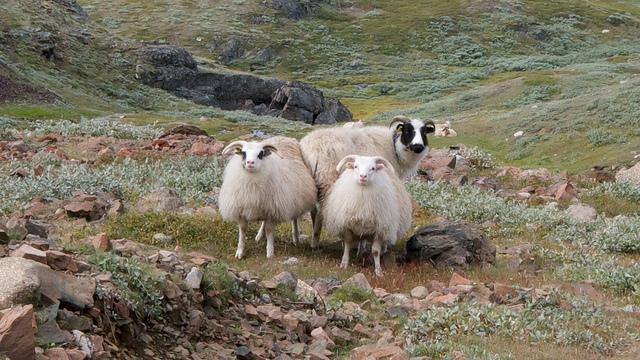Are there rocks in the picture?
Short answer required. Yes. Has the sheep recently been shaved?
Answer briefly. No. How many sheeps are this?
Short answer required. 3. Are there three sheep?
Answer briefly. Yes. 